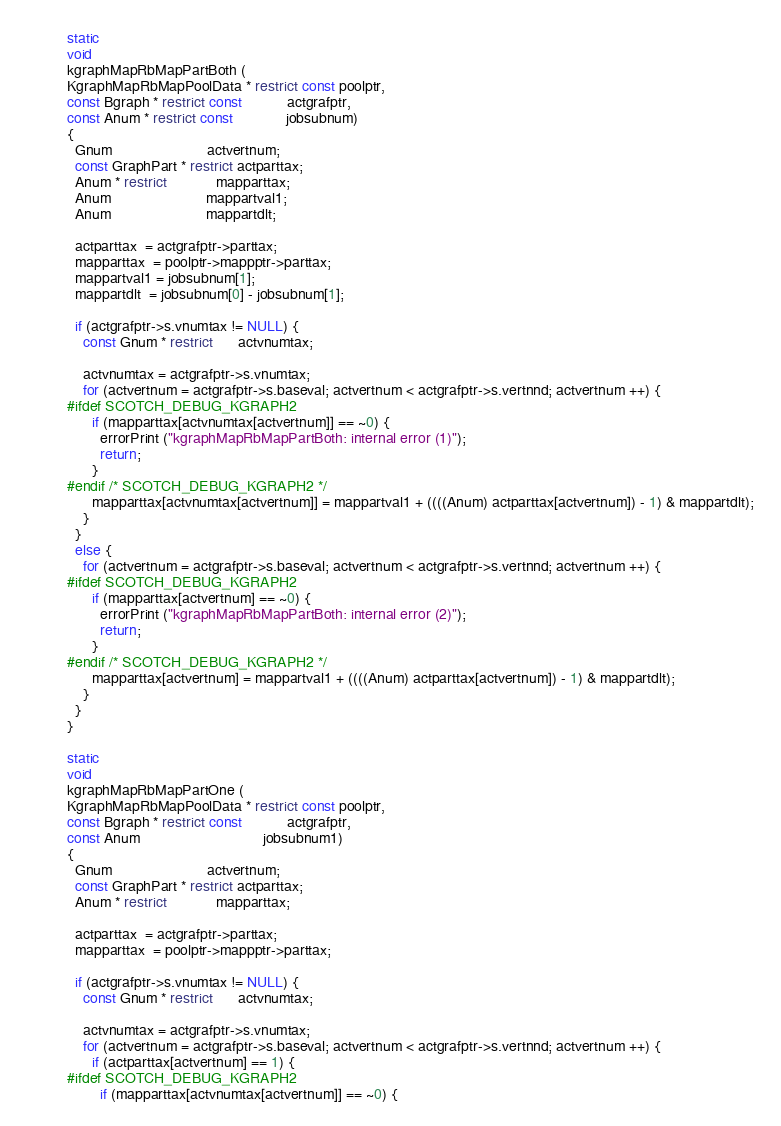Convert code to text. <code><loc_0><loc_0><loc_500><loc_500><_C_>
static
void
kgraphMapRbMapPartBoth (
KgraphMapRbMapPoolData * restrict const poolptr,
const Bgraph * restrict const           actgrafptr,
const Anum * restrict const             jobsubnum)
{
  Gnum                       actvertnum;
  const GraphPart * restrict actparttax;
  Anum * restrict            mapparttax;
  Anum                       mappartval1;
  Anum                       mappartdlt;

  actparttax  = actgrafptr->parttax;
  mapparttax  = poolptr->mappptr->parttax;
  mappartval1 = jobsubnum[1];
  mappartdlt  = jobsubnum[0] - jobsubnum[1];

  if (actgrafptr->s.vnumtax != NULL) {
    const Gnum * restrict      actvnumtax;

    actvnumtax = actgrafptr->s.vnumtax;
    for (actvertnum = actgrafptr->s.baseval; actvertnum < actgrafptr->s.vertnnd; actvertnum ++) {
#ifdef SCOTCH_DEBUG_KGRAPH2
      if (mapparttax[actvnumtax[actvertnum]] == ~0) {
        errorPrint ("kgraphMapRbMapPartBoth: internal error (1)");
        return;
      }
#endif /* SCOTCH_DEBUG_KGRAPH2 */
      mapparttax[actvnumtax[actvertnum]] = mappartval1 + ((((Anum) actparttax[actvertnum]) - 1) & mappartdlt);
    }
  }
  else {
    for (actvertnum = actgrafptr->s.baseval; actvertnum < actgrafptr->s.vertnnd; actvertnum ++) {
#ifdef SCOTCH_DEBUG_KGRAPH2
      if (mapparttax[actvertnum] == ~0) {
        errorPrint ("kgraphMapRbMapPartBoth: internal error (2)");
        return;
      }
#endif /* SCOTCH_DEBUG_KGRAPH2 */
      mapparttax[actvertnum] = mappartval1 + ((((Anum) actparttax[actvertnum]) - 1) & mappartdlt);
    }
  }
}

static
void
kgraphMapRbMapPartOne (
KgraphMapRbMapPoolData * restrict const poolptr,
const Bgraph * restrict const           actgrafptr,
const Anum                              jobsubnum1)
{
  Gnum                       actvertnum;
  const GraphPart * restrict actparttax;
  Anum * restrict            mapparttax;

  actparttax  = actgrafptr->parttax;
  mapparttax  = poolptr->mappptr->parttax;

  if (actgrafptr->s.vnumtax != NULL) {
    const Gnum * restrict      actvnumtax;

    actvnumtax = actgrafptr->s.vnumtax;
    for (actvertnum = actgrafptr->s.baseval; actvertnum < actgrafptr->s.vertnnd; actvertnum ++) {
      if (actparttax[actvertnum] == 1) {
#ifdef SCOTCH_DEBUG_KGRAPH2
        if (mapparttax[actvnumtax[actvertnum]] == ~0) {</code> 